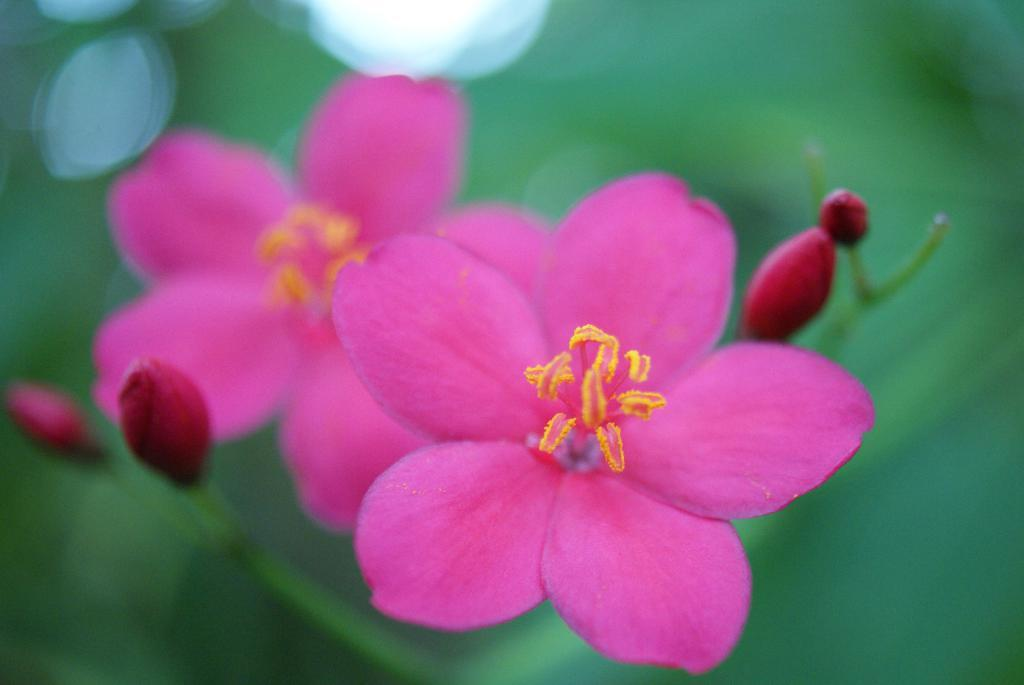What type of flowers can be seen in the image? There are pink color flowers in the image. How would you describe the background of the image? The background of the image is blurred. What color is the background of the image? The background color is green. What type of amusement can be seen in the image? There is no amusement present in the image; it features pink color flowers and a green background. Are there any pickles visible in the image? There are no pickles present in the image. 